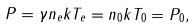Convert formula to latex. <formula><loc_0><loc_0><loc_500><loc_500>P = \gamma n _ { e } k T _ { e } = n _ { 0 } k T _ { 0 } = P _ { 0 } ,</formula> 